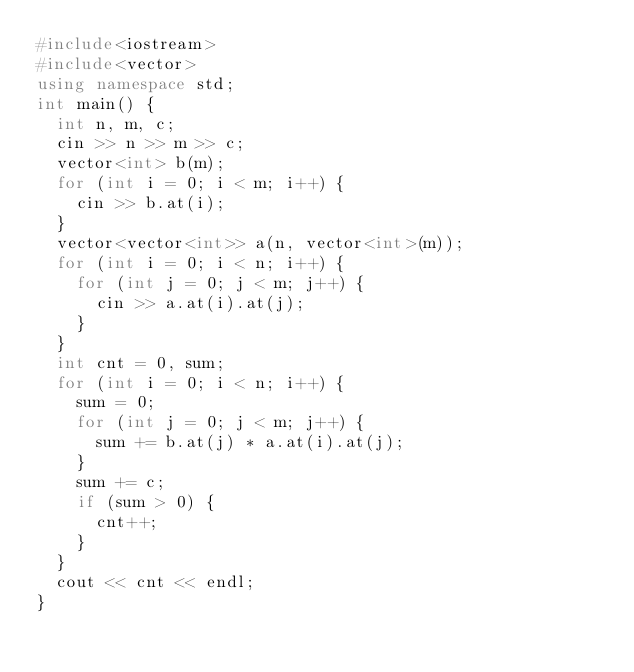<code> <loc_0><loc_0><loc_500><loc_500><_C++_>#include<iostream>
#include<vector>
using namespace std;
int main() {
	int n, m, c;
	cin >> n >> m >> c;
	vector<int> b(m);
	for (int i = 0; i < m; i++) {
		cin >> b.at(i);
	}
	vector<vector<int>> a(n, vector<int>(m));
	for (int i = 0; i < n; i++) {
		for (int j = 0; j < m; j++) {
			cin >> a.at(i).at(j);
		}
	}
	int cnt = 0, sum;
	for (int i = 0; i < n; i++) {
		sum = 0;
		for (int j = 0; j < m; j++) {
			sum += b.at(j) * a.at(i).at(j);
		}
		sum += c;
		if (sum > 0) {
			cnt++;
		}
	}
	cout << cnt << endl;
}</code> 